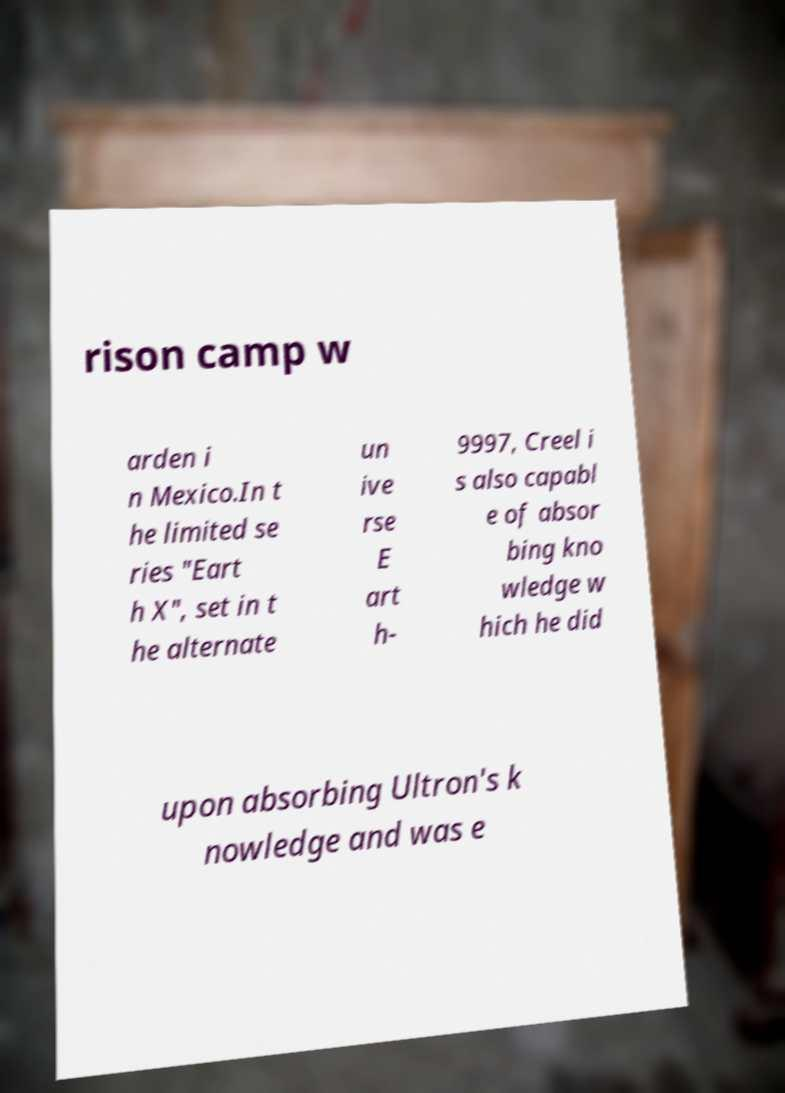For documentation purposes, I need the text within this image transcribed. Could you provide that? rison camp w arden i n Mexico.In t he limited se ries "Eart h X", set in t he alternate un ive rse E art h- 9997, Creel i s also capabl e of absor bing kno wledge w hich he did upon absorbing Ultron's k nowledge and was e 